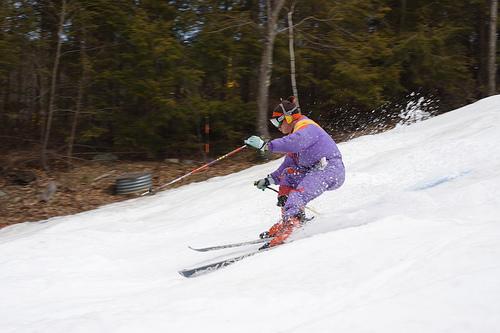What is the season?
Write a very short answer. Winter. Is this a person who is athletic?
Keep it brief. Yes. Why is this person bending their knees?
Concise answer only. Skiing. Is she in the forest?
Short answer required. No. What is covering the ground?
Keep it brief. Snow. Is the person skiing wearing purple?
Concise answer only. Yes. 